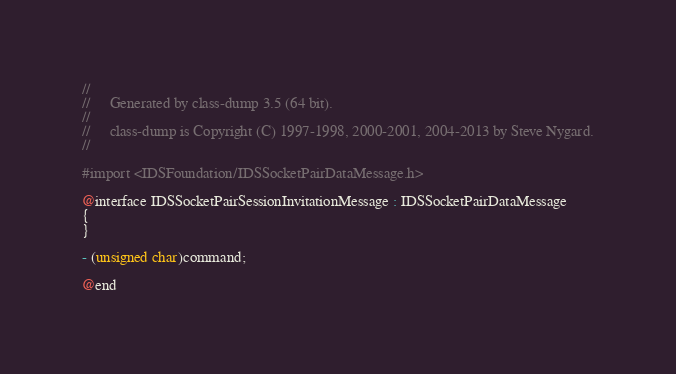<code> <loc_0><loc_0><loc_500><loc_500><_C_>//
//     Generated by class-dump 3.5 (64 bit).
//
//     class-dump is Copyright (C) 1997-1998, 2000-2001, 2004-2013 by Steve Nygard.
//

#import <IDSFoundation/IDSSocketPairDataMessage.h>

@interface IDSSocketPairSessionInvitationMessage : IDSSocketPairDataMessage
{
}

- (unsigned char)command;

@end

</code> 